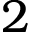Convert formula to latex. <formula><loc_0><loc_0><loc_500><loc_500>2</formula> 